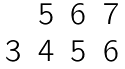Convert formula to latex. <formula><loc_0><loc_0><loc_500><loc_500>\begin{matrix} & 5 & 6 & 7 \\ 3 & 4 & 5 & 6 \end{matrix}</formula> 